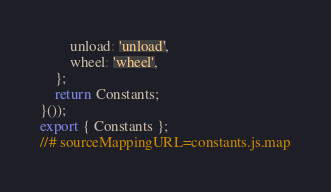<code> <loc_0><loc_0><loc_500><loc_500><_JavaScript_>        unload: 'unload',
        wheel: 'wheel',
    };
    return Constants;
}());
export { Constants };
//# sourceMappingURL=constants.js.map</code> 